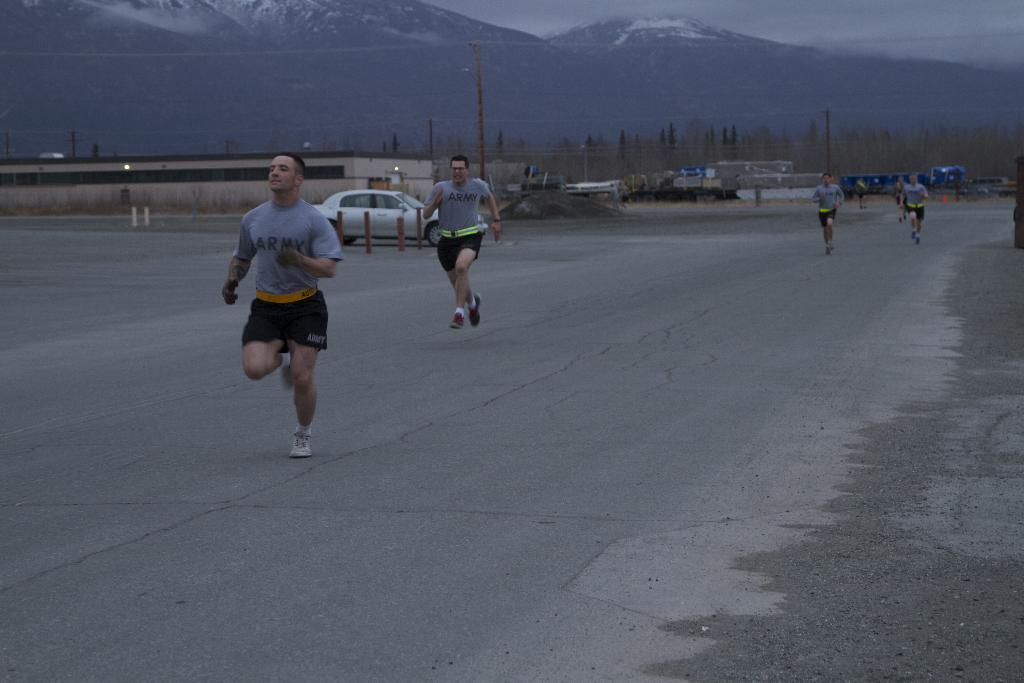How many people are in the image? There are four persons in the image. What are the persons wearing? The persons are wearing clothes. What activity are the persons engaged in? The persons are running on the road. What other objects can be seen in the image? There is a car beside a shed and a pole in the image. What is visible in the background of the image? Mountains are visible at the top of the image. Can you tell me how many umbrellas are being used by the persons in the image? There are no umbrellas present in the image; the persons are running on the road without any umbrellas. What type of scissors can be seen cutting the pole in the image? There are no scissors or any cutting activity involving the pole in the image. 